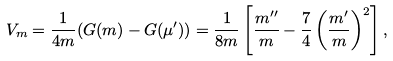Convert formula to latex. <formula><loc_0><loc_0><loc_500><loc_500>V _ { m } = \frac { 1 } { 4 m } ( G ( m ) - G ( \mu ^ { \prime } ) ) = \frac { 1 } { 8 m } \left [ \frac { m ^ { \prime \prime } } { m } - \frac { 7 } { 4 } \left ( \frac { m ^ { \prime } } { m } \right ) ^ { 2 } \right ] ,</formula> 